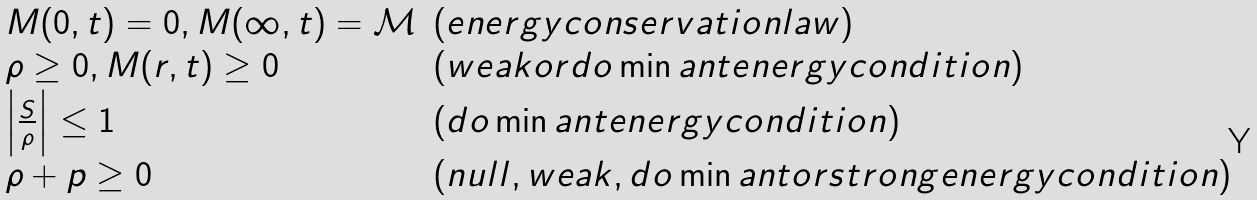Convert formula to latex. <formula><loc_0><loc_0><loc_500><loc_500>\begin{array} { l l } M ( 0 , t ) = 0 , M ( \infty , t ) = \mathcal { M } & ( e n e r g y c o n s e r v a t i o n l a w ) \\ \rho \geq 0 , M ( r , t ) \geq 0 & ( w e a k o r d o \min a n t e n e r g y c o n d i t i o n ) \\ \left | \frac { S } { \rho } \right | \leq 1 & ( d o \min a n t e n e r g y c o n d i t i o n ) \\ \rho + p \geq 0 & ( n u l l , w e a k , d o \min a n t o r s t r o n g e n e r g y c o n d i t i o n ) \end{array}</formula> 